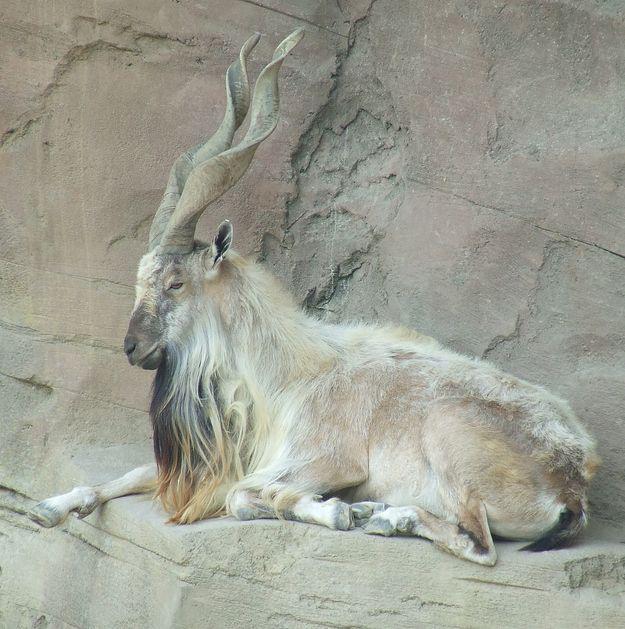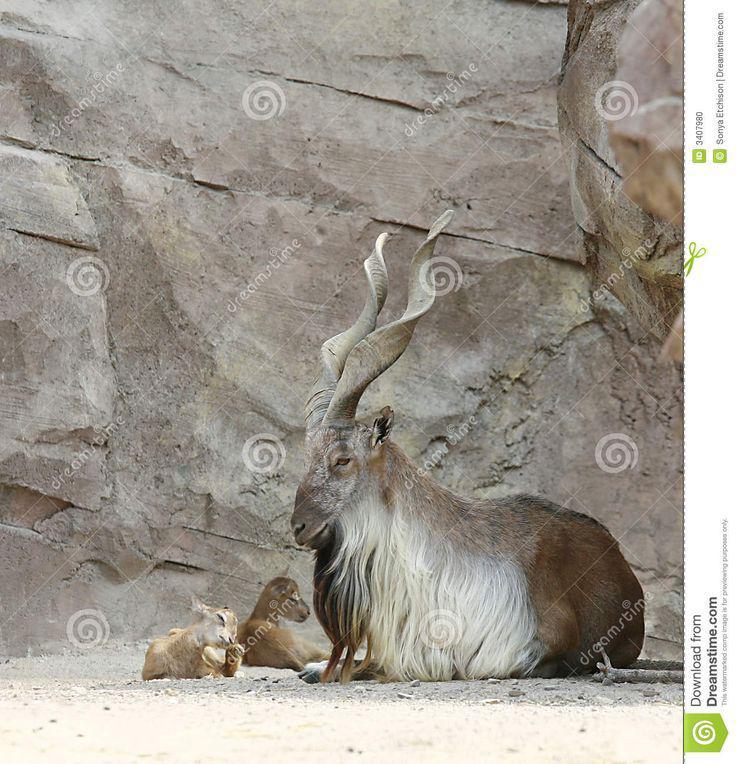The first image is the image on the left, the second image is the image on the right. For the images shown, is this caption "Each image contains one horned animal in front of a wall of rock, and the animals in the left and right images face the same way and have very similar body positions." true? Answer yes or no. Yes. The first image is the image on the left, the second image is the image on the right. Examine the images to the left and right. Is the description "The left and right image contains the same number of goats facing the same direction." accurate? Answer yes or no. Yes. 